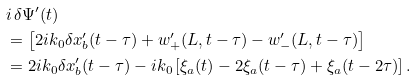Convert formula to latex. <formula><loc_0><loc_0><loc_500><loc_500>& i \, \delta \Psi ^ { \prime } ( t ) \\ & = \left [ 2 i k _ { 0 } \delta x ^ { \prime } _ { b } ( t - \tau ) + w ^ { \prime } _ { + } ( L , t - \tau ) - w ^ { \prime } _ { - } ( L , t - \tau ) \right ] \\ & = 2 i k _ { 0 } \delta x ^ { \prime } _ { b } ( t - \tau ) - i k _ { 0 } \left [ \xi _ { a } ( t ) - 2 \xi _ { a } ( t - \tau ) + \xi _ { a } ( t - 2 \tau ) \right ] .</formula> 